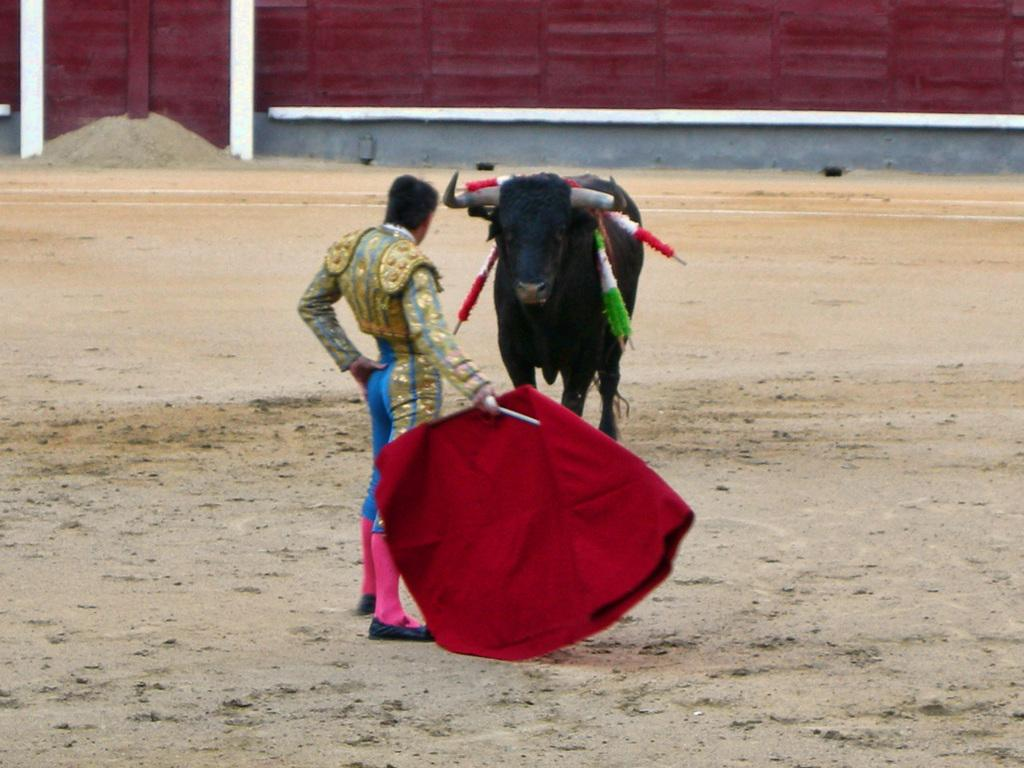What is the person in the image doing? The person is standing in the image. What is the person holding in the image? The person is holding a red cloth. What other animal or object can be seen in the image? There is a bull visible in the image. What type of plants can be seen growing in the cup in the image? There is no cup or plants present in the image. 